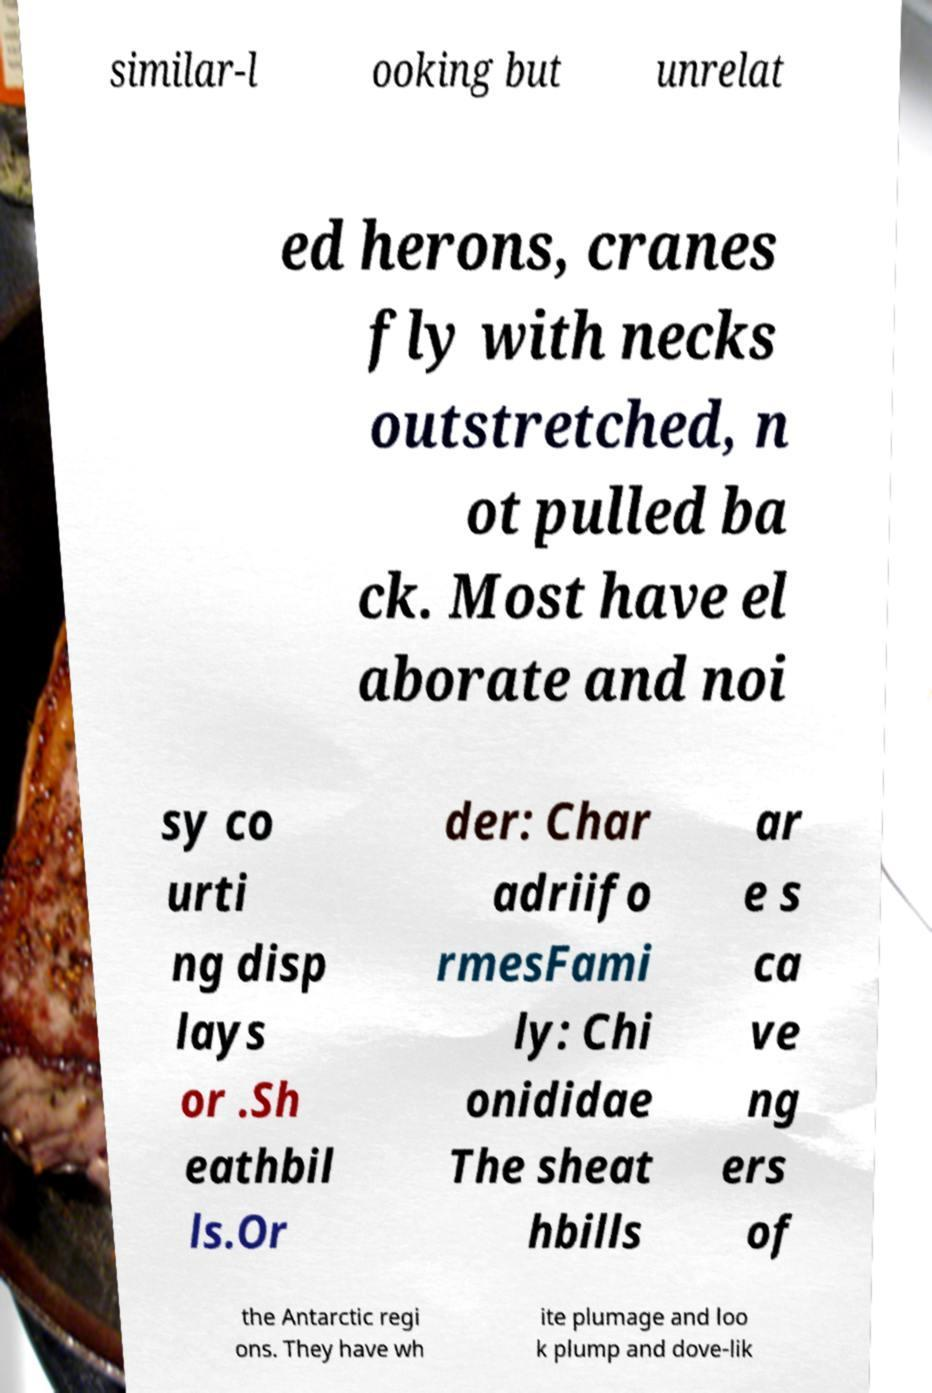Could you extract and type out the text from this image? similar-l ooking but unrelat ed herons, cranes fly with necks outstretched, n ot pulled ba ck. Most have el aborate and noi sy co urti ng disp lays or .Sh eathbil ls.Or der: Char adriifo rmesFami ly: Chi onididae The sheat hbills ar e s ca ve ng ers of the Antarctic regi ons. They have wh ite plumage and loo k plump and dove-lik 